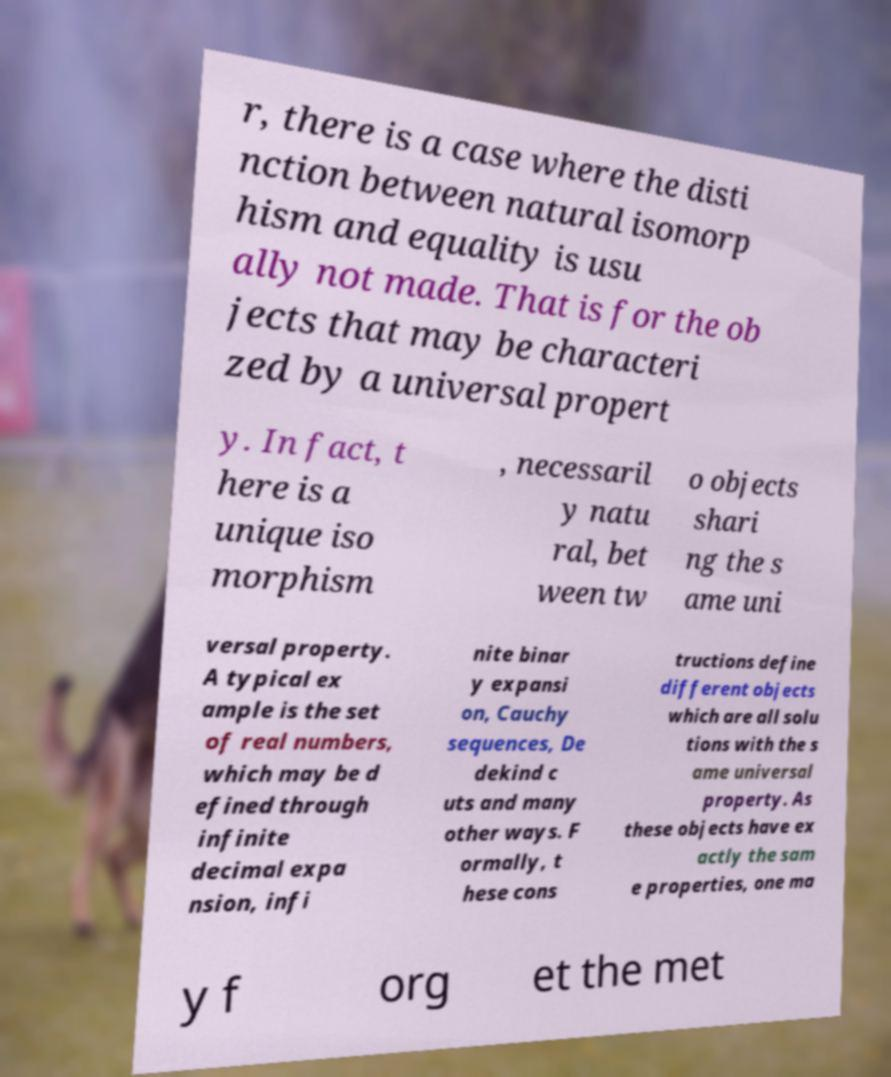Can you read and provide the text displayed in the image?This photo seems to have some interesting text. Can you extract and type it out for me? r, there is a case where the disti nction between natural isomorp hism and equality is usu ally not made. That is for the ob jects that may be characteri zed by a universal propert y. In fact, t here is a unique iso morphism , necessaril y natu ral, bet ween tw o objects shari ng the s ame uni versal property. A typical ex ample is the set of real numbers, which may be d efined through infinite decimal expa nsion, infi nite binar y expansi on, Cauchy sequences, De dekind c uts and many other ways. F ormally, t hese cons tructions define different objects which are all solu tions with the s ame universal property. As these objects have ex actly the sam e properties, one ma y f org et the met 